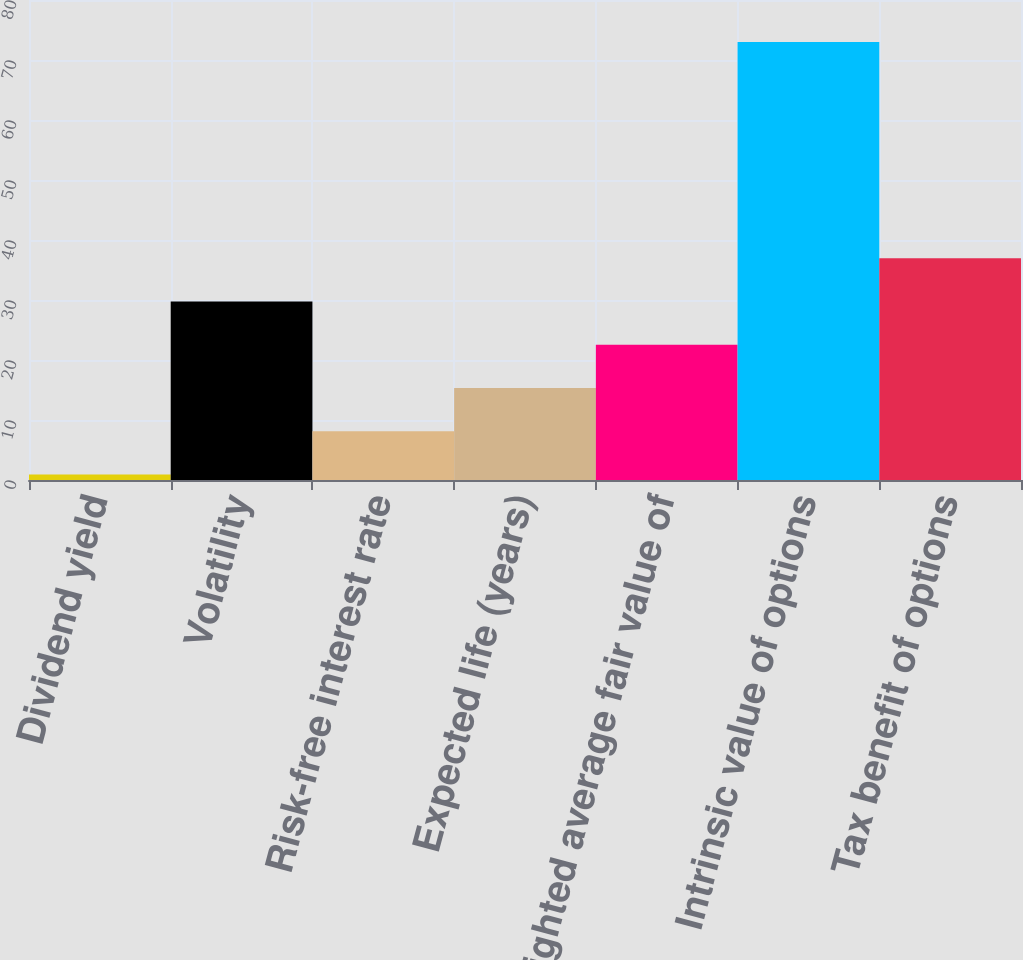Convert chart. <chart><loc_0><loc_0><loc_500><loc_500><bar_chart><fcel>Dividend yield<fcel>Volatility<fcel>Risk-free interest rate<fcel>Expected life (years)<fcel>Weighted average fair value of<fcel>Intrinsic value of options<fcel>Tax benefit of options<nl><fcel>0.9<fcel>29.74<fcel>8.11<fcel>15.32<fcel>22.53<fcel>73<fcel>36.95<nl></chart> 